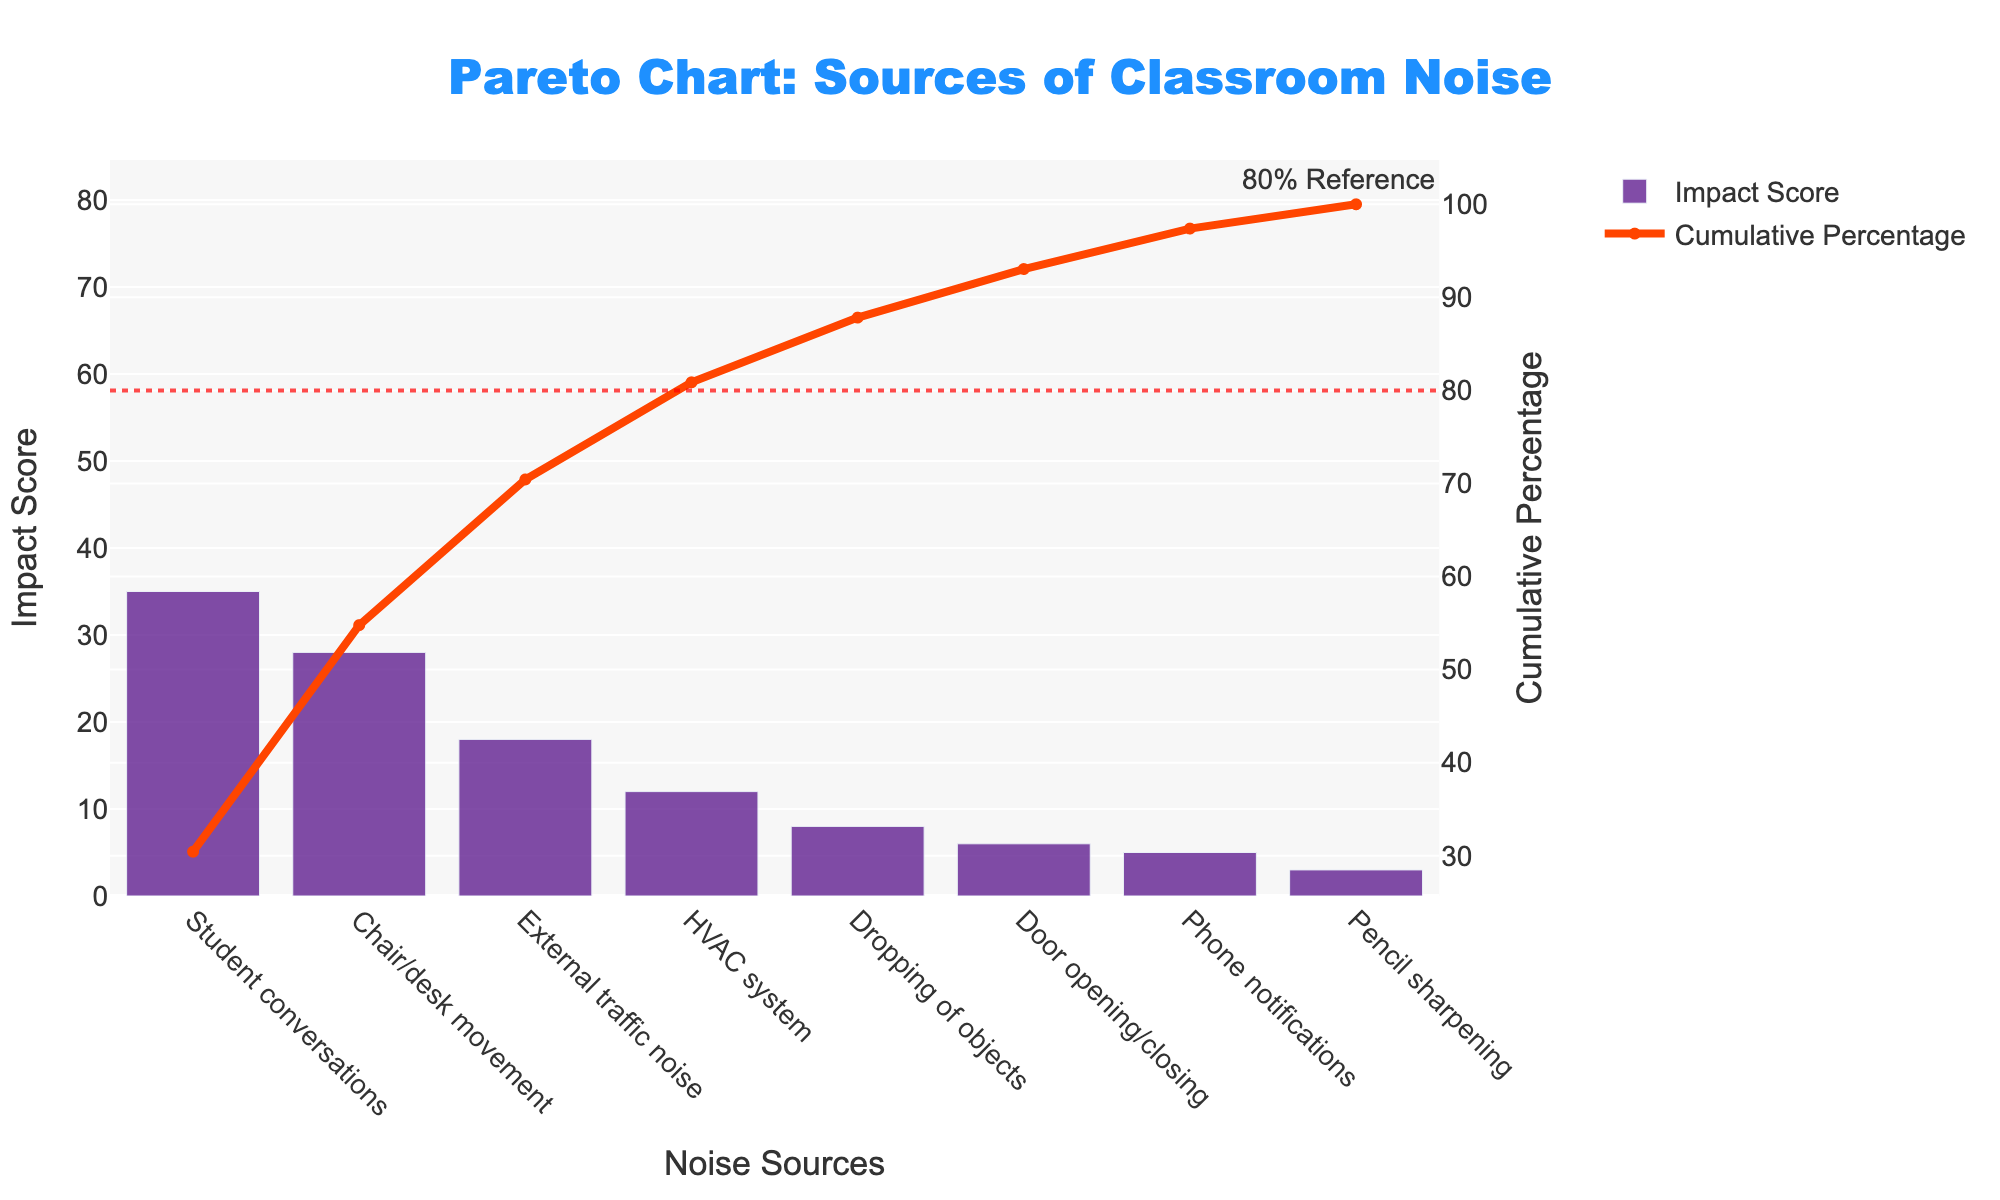What's the title of the chart? The title is usually displayed at the top of the chart. From the given code, the title of the chart is "Pareto Chart: Sources of Classroom Noise."
Answer: Pareto Chart: Sources of Classroom Noise What are the two axes labeled? In the chart, the x-axis typically has the label for categories, and the y-axes label the measurements. The x-axis is labeled "Noise Sources," the primary y-axis is labeled "Impact Score," and the secondary y-axis is labeled "Cumulative Percentage."
Answer: Noise Sources, Impact Score, Cumulative Percentage What noise source has the highest impact score? The highest impact score can be found by looking at the tallest bar in the chart. According to the sorted data, "Student conversations" have the highest impact score at 35.
Answer: Student conversations What is the cumulative percentage at the second noise source? To find this, locate the second noise source bar and refer to the line chart representing cumulative percentage. The second noise source, "Chair/desk movement," corresponds to an approximate cumulative percentage of 54.3%.
Answer: ~54.3% Which noise sources combined contribute to around 80% of the total impact? Add the cumulative percentages until you get close to 80%. "Student conversations" (about 35%), “Chair/desk movement” (about 54.3%), and "External traffic noise" (about 77.1%) combine to reach just around 80%.
Answer: Student conversations, Chair/desk movement, External traffic noise What is the difference in the impact scores between "External traffic noise" and "Phone notifications"? Subtract the impact score of "Phone notifications" from that of "External traffic noise." From the data: 18 (External traffic noise) - 5 (Phone notifications) = 13.
Answer: 13 How many noise sources contribute to more than 50% of the total impact score? Check the cumulative percentages and count the number of sources until the cumulative percentage exceeds 50%. "Student conversations" and "Chair/desk movement" have cumulative percentages of about 35% and 54.3%, respectively. So, 2 noise sources.
Answer: 2 What is the relative ranking of the "Door opening/closing" in terms of impact score? Arrange the sources by descending order of impact scores. "Door opening/closing" is ranked 6th.
Answer: 6th Which noise source has the lowest impact score? The shortest bar or the bottom of the sorted list identifies the noise source with the lowest impact score, which is "Pencil sharpening" at 3.
Answer: Pencil sharpening What is the impact score's median value? Arrange the impact scores in ascending order and find the middle value. The scores are (3, 5, 6, 8, 12, 18, 28, 35). The median is the average of the 4th and 5th values: (8+12)/2 = 10.
Answer: 10 